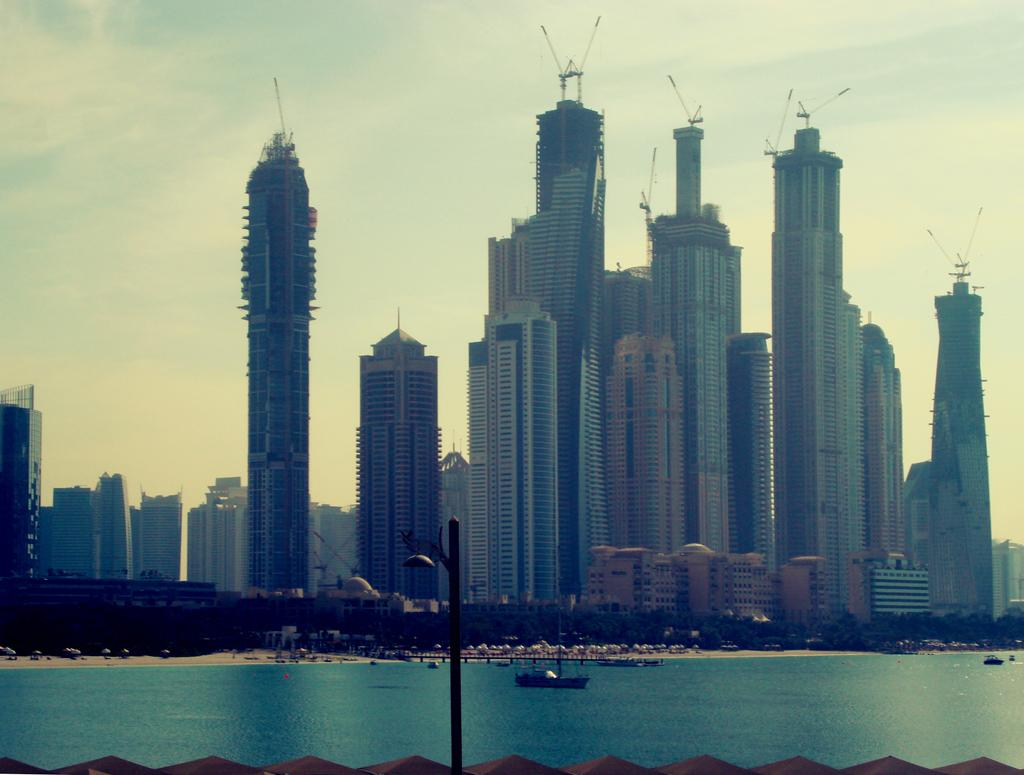What type of structures can be seen in the image? There are buildings in the image. What other object can be seen in the image besides the buildings? There is a light pole in the image. What is present on the surface of the water in the image? Boats are present on the surface of the sea in the image. What can be seen in the background of the image? The sky is visible in the background of the image. How many sacks are being carried by the people in the image? There are no people or sacks present in the image. What type of flight is taking place in the image? There is no flight present in the image; it features buildings, a light pole, boats, and the sky. 